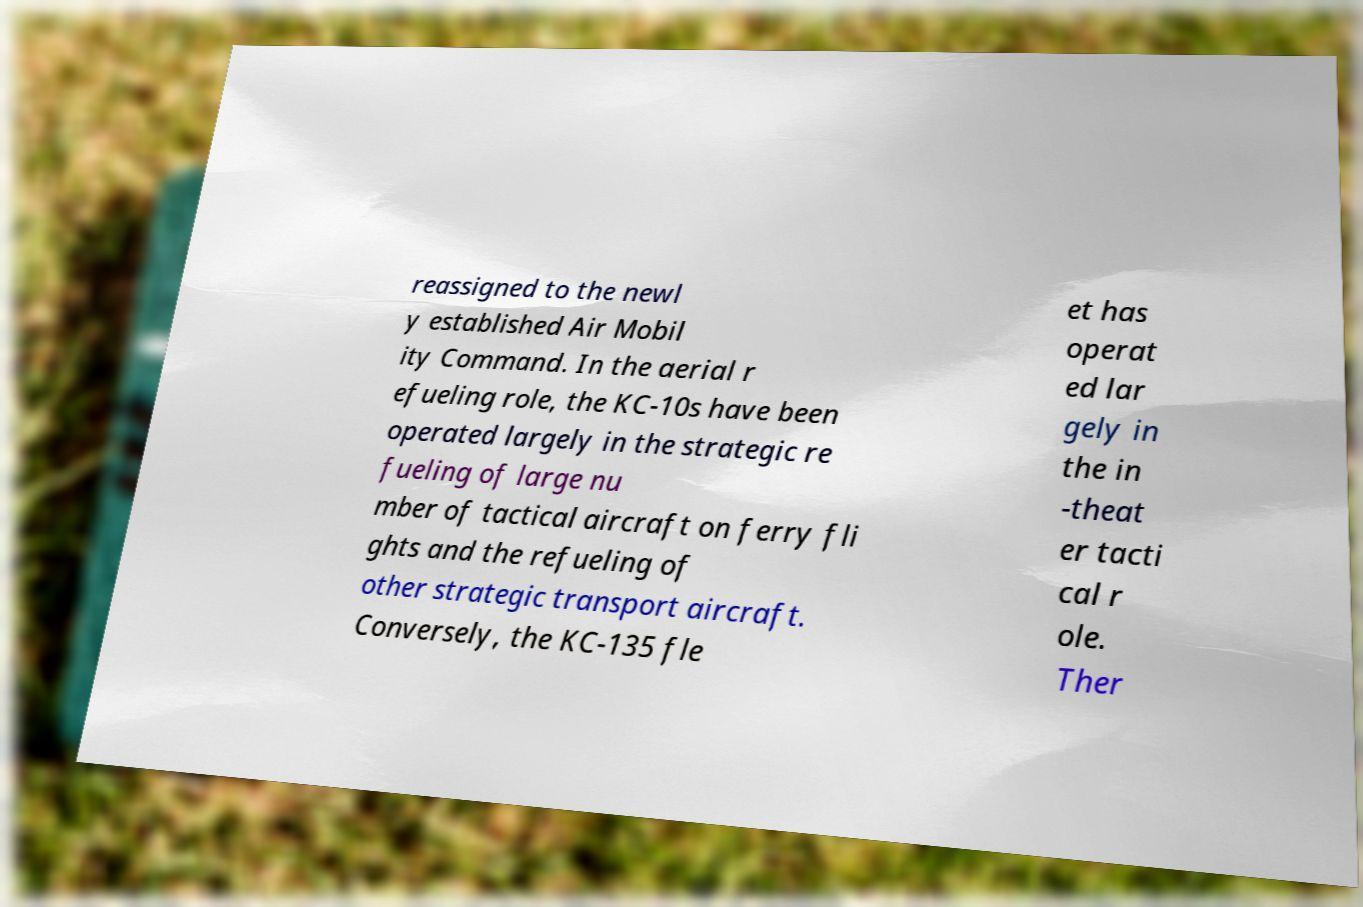Could you extract and type out the text from this image? reassigned to the newl y established Air Mobil ity Command. In the aerial r efueling role, the KC-10s have been operated largely in the strategic re fueling of large nu mber of tactical aircraft on ferry fli ghts and the refueling of other strategic transport aircraft. Conversely, the KC-135 fle et has operat ed lar gely in the in -theat er tacti cal r ole. Ther 